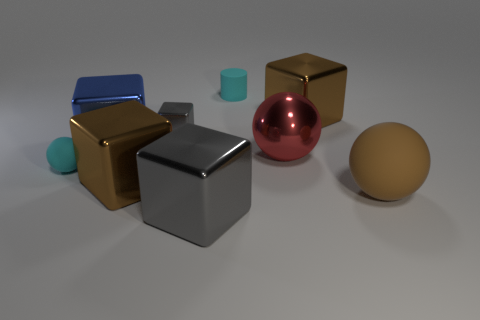Subtract all gray cylinders. How many gray cubes are left? 2 Subtract all big metal blocks. How many blocks are left? 1 Subtract all gray cubes. How many cubes are left? 3 Add 1 gray cubes. How many objects exist? 10 Subtract 1 cubes. How many cubes are left? 4 Subtract all cylinders. How many objects are left? 8 Subtract all big green metal things. Subtract all cyan objects. How many objects are left? 7 Add 9 blue metallic cubes. How many blue metallic cubes are left? 10 Add 1 small brown shiny cylinders. How many small brown shiny cylinders exist? 1 Subtract 0 yellow balls. How many objects are left? 9 